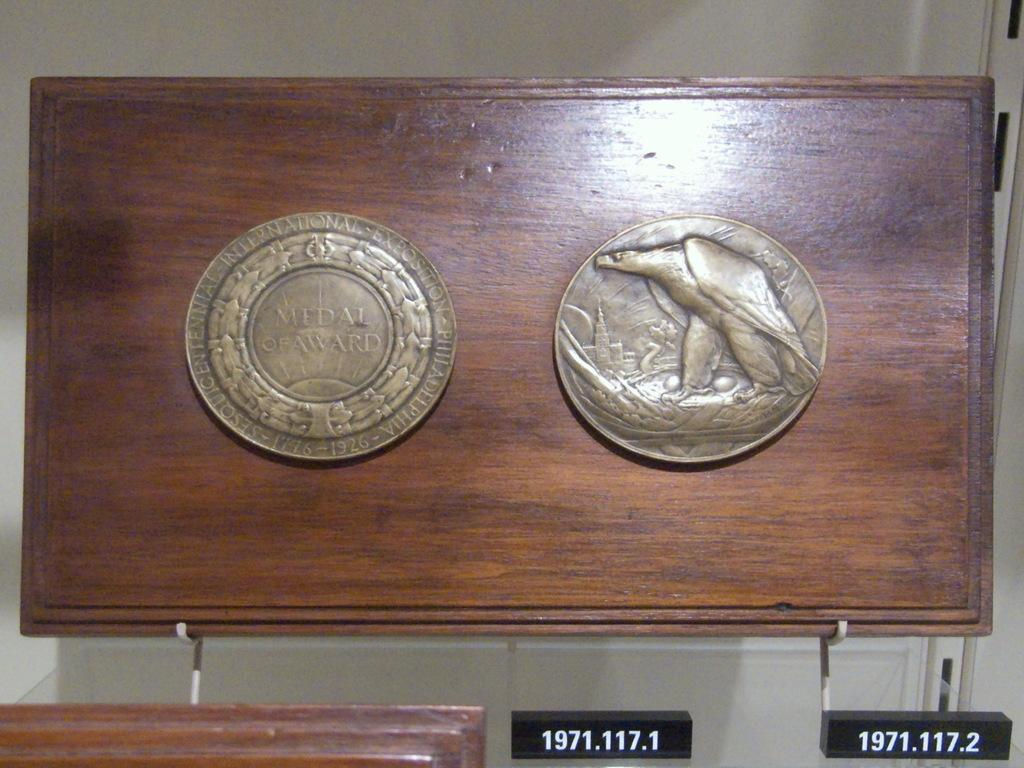Provide a one-sentence caption for the provided image. two round medals one of which has Medal of Award written on it. 